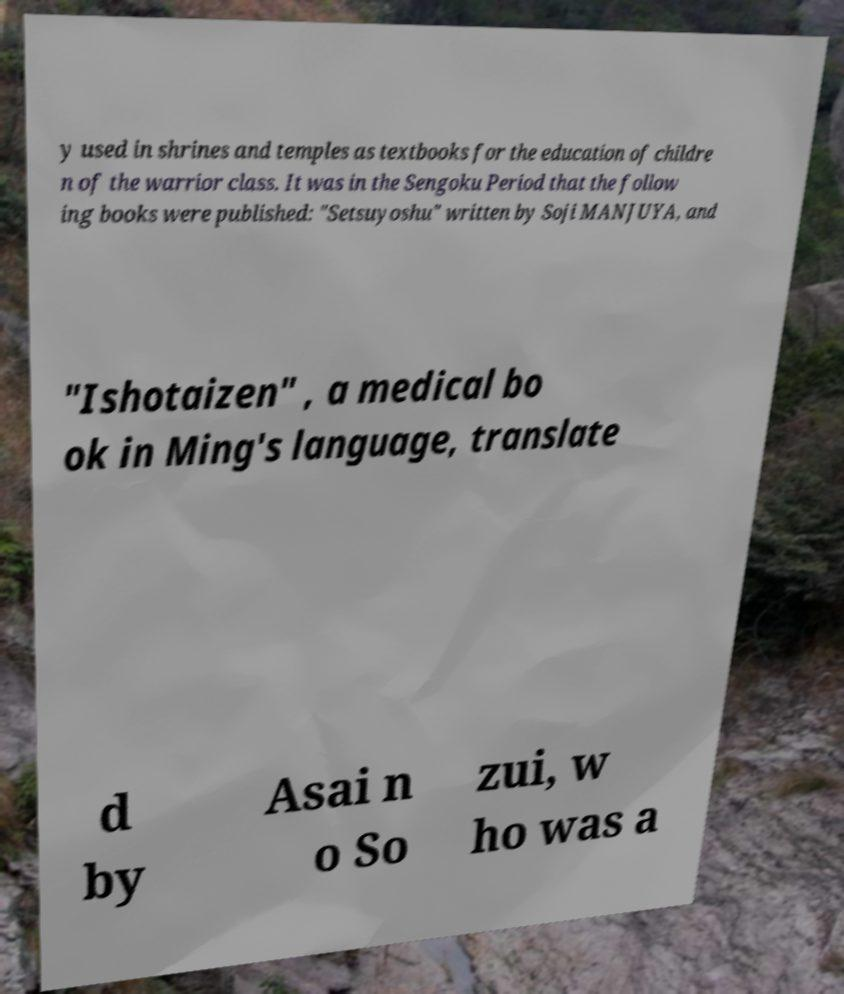Could you assist in decoding the text presented in this image and type it out clearly? y used in shrines and temples as textbooks for the education of childre n of the warrior class. It was in the Sengoku Period that the follow ing books were published: "Setsuyoshu" written by Soji MANJUYA, and "Ishotaizen" , a medical bo ok in Ming's language, translate d by Asai n o So zui, w ho was a 